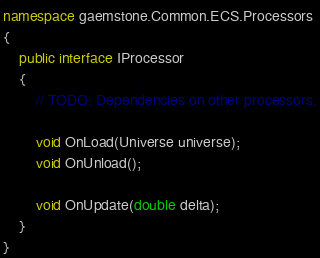<code> <loc_0><loc_0><loc_500><loc_500><_C#_>
namespace gaemstone.Common.ECS.Processors
{
	public interface IProcessor
	{
		// TODO: Dependencies on other processors.

		void OnLoad(Universe universe);
		void OnUnload();

		void OnUpdate(double delta);
	}
}
</code> 